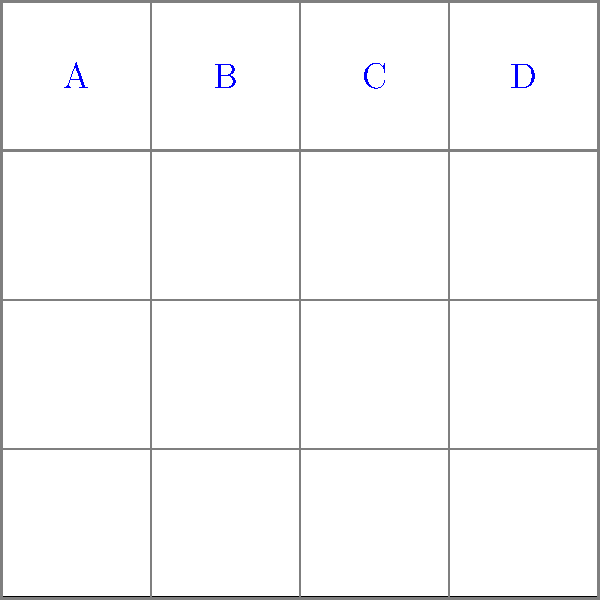You're designing a new uniform concept for a sports team and need to determine the optimal spacing for player numbers on the back. Using a 4x4 grid system as shown in the diagram, where each cell represents 1/16 of the uniform width, you've placed four numbers (A, B, C, and D) in the top row. If the minimum acceptable spacing between numbers is 1/8 of the uniform width, what is the maximum number of digits that can fit on the uniform while maintaining this minimum spacing? Let's approach this step-by-step:

1) First, we need to understand the grid system:
   - The uniform is divided into a 4x4 grid, so each cell is 1/4 of the uniform's width and height.
   - Each number (A, B, C, D) occupies one cell, which is 1/4 of the uniform's width.

2) The minimum acceptable spacing is 1/8 of the uniform width:
   - This is equivalent to 2 cells in our 4x4 grid system (since each cell is 1/4 of the width).

3) Let's analyze the current spacing:
   - Between A and B: 1 cell
   - Between B and C: 1 cell
   - Between C and D: 1 cell

4) To meet the minimum spacing requirement:
   - We need to remove every other number to have 2 cells between each number.

5) The maximum number of digits that can fit:
   - We can keep either A and C, or B and D.
   - This means we can fit 2 digits while maintaining the minimum spacing.

Therefore, the maximum number of digits that can fit on the uniform while maintaining the minimum spacing of 1/8 of the uniform width is 2.
Answer: 2 digits 